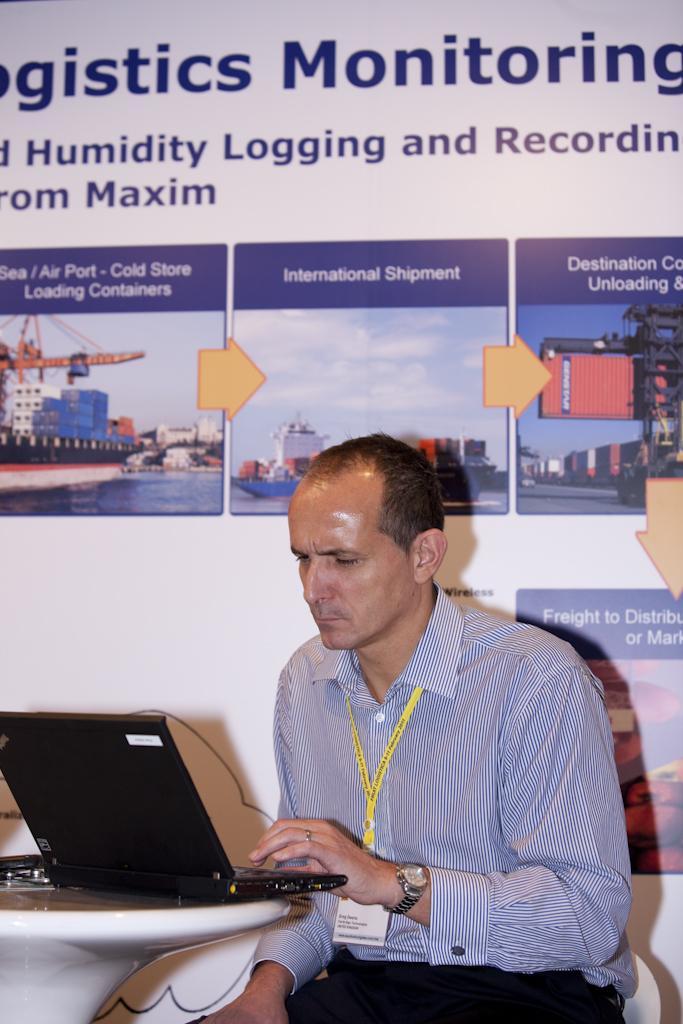How would you summarize this image in a sentence or two? In the center of the image we can see a man sitting, before him there is a table and there is a laptop placed on the table. In the background there is a board placed on the wall. 